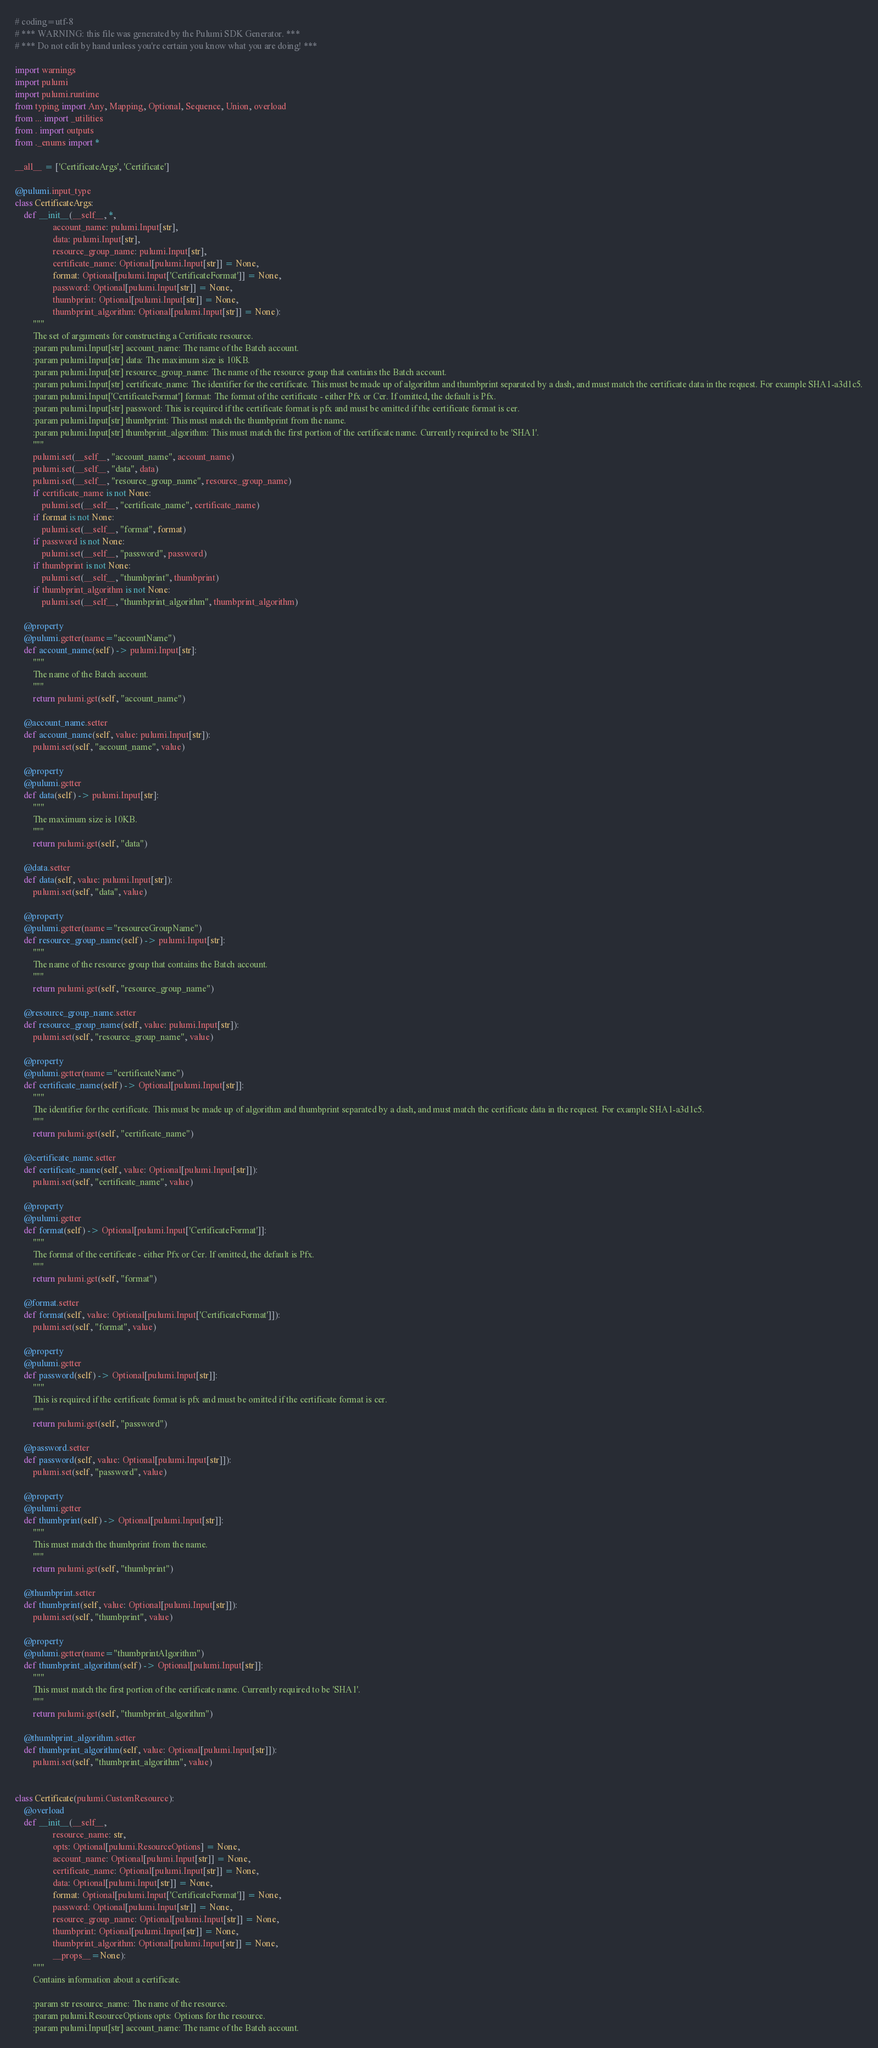<code> <loc_0><loc_0><loc_500><loc_500><_Python_># coding=utf-8
# *** WARNING: this file was generated by the Pulumi SDK Generator. ***
# *** Do not edit by hand unless you're certain you know what you are doing! ***

import warnings
import pulumi
import pulumi.runtime
from typing import Any, Mapping, Optional, Sequence, Union, overload
from ... import _utilities
from . import outputs
from ._enums import *

__all__ = ['CertificateArgs', 'Certificate']

@pulumi.input_type
class CertificateArgs:
    def __init__(__self__, *,
                 account_name: pulumi.Input[str],
                 data: pulumi.Input[str],
                 resource_group_name: pulumi.Input[str],
                 certificate_name: Optional[pulumi.Input[str]] = None,
                 format: Optional[pulumi.Input['CertificateFormat']] = None,
                 password: Optional[pulumi.Input[str]] = None,
                 thumbprint: Optional[pulumi.Input[str]] = None,
                 thumbprint_algorithm: Optional[pulumi.Input[str]] = None):
        """
        The set of arguments for constructing a Certificate resource.
        :param pulumi.Input[str] account_name: The name of the Batch account.
        :param pulumi.Input[str] data: The maximum size is 10KB.
        :param pulumi.Input[str] resource_group_name: The name of the resource group that contains the Batch account.
        :param pulumi.Input[str] certificate_name: The identifier for the certificate. This must be made up of algorithm and thumbprint separated by a dash, and must match the certificate data in the request. For example SHA1-a3d1c5.
        :param pulumi.Input['CertificateFormat'] format: The format of the certificate - either Pfx or Cer. If omitted, the default is Pfx.
        :param pulumi.Input[str] password: This is required if the certificate format is pfx and must be omitted if the certificate format is cer.
        :param pulumi.Input[str] thumbprint: This must match the thumbprint from the name.
        :param pulumi.Input[str] thumbprint_algorithm: This must match the first portion of the certificate name. Currently required to be 'SHA1'.
        """
        pulumi.set(__self__, "account_name", account_name)
        pulumi.set(__self__, "data", data)
        pulumi.set(__self__, "resource_group_name", resource_group_name)
        if certificate_name is not None:
            pulumi.set(__self__, "certificate_name", certificate_name)
        if format is not None:
            pulumi.set(__self__, "format", format)
        if password is not None:
            pulumi.set(__self__, "password", password)
        if thumbprint is not None:
            pulumi.set(__self__, "thumbprint", thumbprint)
        if thumbprint_algorithm is not None:
            pulumi.set(__self__, "thumbprint_algorithm", thumbprint_algorithm)

    @property
    @pulumi.getter(name="accountName")
    def account_name(self) -> pulumi.Input[str]:
        """
        The name of the Batch account.
        """
        return pulumi.get(self, "account_name")

    @account_name.setter
    def account_name(self, value: pulumi.Input[str]):
        pulumi.set(self, "account_name", value)

    @property
    @pulumi.getter
    def data(self) -> pulumi.Input[str]:
        """
        The maximum size is 10KB.
        """
        return pulumi.get(self, "data")

    @data.setter
    def data(self, value: pulumi.Input[str]):
        pulumi.set(self, "data", value)

    @property
    @pulumi.getter(name="resourceGroupName")
    def resource_group_name(self) -> pulumi.Input[str]:
        """
        The name of the resource group that contains the Batch account.
        """
        return pulumi.get(self, "resource_group_name")

    @resource_group_name.setter
    def resource_group_name(self, value: pulumi.Input[str]):
        pulumi.set(self, "resource_group_name", value)

    @property
    @pulumi.getter(name="certificateName")
    def certificate_name(self) -> Optional[pulumi.Input[str]]:
        """
        The identifier for the certificate. This must be made up of algorithm and thumbprint separated by a dash, and must match the certificate data in the request. For example SHA1-a3d1c5.
        """
        return pulumi.get(self, "certificate_name")

    @certificate_name.setter
    def certificate_name(self, value: Optional[pulumi.Input[str]]):
        pulumi.set(self, "certificate_name", value)

    @property
    @pulumi.getter
    def format(self) -> Optional[pulumi.Input['CertificateFormat']]:
        """
        The format of the certificate - either Pfx or Cer. If omitted, the default is Pfx.
        """
        return pulumi.get(self, "format")

    @format.setter
    def format(self, value: Optional[pulumi.Input['CertificateFormat']]):
        pulumi.set(self, "format", value)

    @property
    @pulumi.getter
    def password(self) -> Optional[pulumi.Input[str]]:
        """
        This is required if the certificate format is pfx and must be omitted if the certificate format is cer.
        """
        return pulumi.get(self, "password")

    @password.setter
    def password(self, value: Optional[pulumi.Input[str]]):
        pulumi.set(self, "password", value)

    @property
    @pulumi.getter
    def thumbprint(self) -> Optional[pulumi.Input[str]]:
        """
        This must match the thumbprint from the name.
        """
        return pulumi.get(self, "thumbprint")

    @thumbprint.setter
    def thumbprint(self, value: Optional[pulumi.Input[str]]):
        pulumi.set(self, "thumbprint", value)

    @property
    @pulumi.getter(name="thumbprintAlgorithm")
    def thumbprint_algorithm(self) -> Optional[pulumi.Input[str]]:
        """
        This must match the first portion of the certificate name. Currently required to be 'SHA1'.
        """
        return pulumi.get(self, "thumbprint_algorithm")

    @thumbprint_algorithm.setter
    def thumbprint_algorithm(self, value: Optional[pulumi.Input[str]]):
        pulumi.set(self, "thumbprint_algorithm", value)


class Certificate(pulumi.CustomResource):
    @overload
    def __init__(__self__,
                 resource_name: str,
                 opts: Optional[pulumi.ResourceOptions] = None,
                 account_name: Optional[pulumi.Input[str]] = None,
                 certificate_name: Optional[pulumi.Input[str]] = None,
                 data: Optional[pulumi.Input[str]] = None,
                 format: Optional[pulumi.Input['CertificateFormat']] = None,
                 password: Optional[pulumi.Input[str]] = None,
                 resource_group_name: Optional[pulumi.Input[str]] = None,
                 thumbprint: Optional[pulumi.Input[str]] = None,
                 thumbprint_algorithm: Optional[pulumi.Input[str]] = None,
                 __props__=None):
        """
        Contains information about a certificate.

        :param str resource_name: The name of the resource.
        :param pulumi.ResourceOptions opts: Options for the resource.
        :param pulumi.Input[str] account_name: The name of the Batch account.</code> 